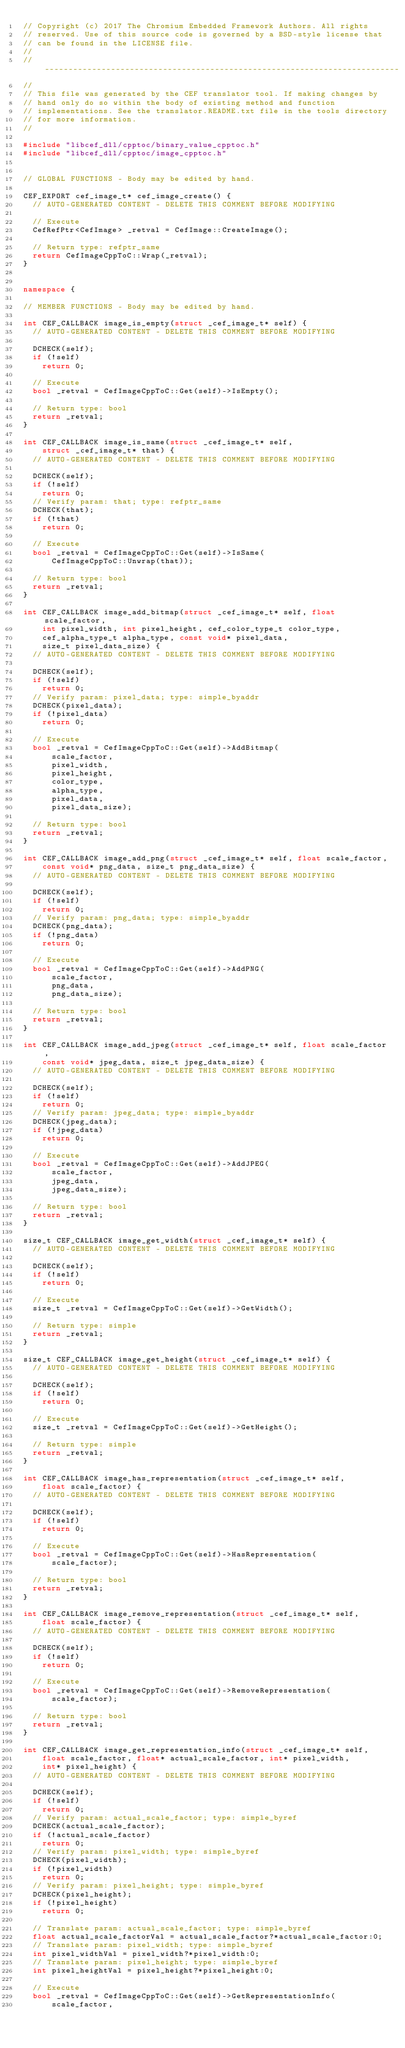<code> <loc_0><loc_0><loc_500><loc_500><_C++_>// Copyright (c) 2017 The Chromium Embedded Framework Authors. All rights
// reserved. Use of this source code is governed by a BSD-style license that
// can be found in the LICENSE file.
//
// ---------------------------------------------------------------------------
//
// This file was generated by the CEF translator tool. If making changes by
// hand only do so within the body of existing method and function
// implementations. See the translator.README.txt file in the tools directory
// for more information.
//

#include "libcef_dll/cpptoc/binary_value_cpptoc.h"
#include "libcef_dll/cpptoc/image_cpptoc.h"


// GLOBAL FUNCTIONS - Body may be edited by hand.

CEF_EXPORT cef_image_t* cef_image_create() {
  // AUTO-GENERATED CONTENT - DELETE THIS COMMENT BEFORE MODIFYING

  // Execute
  CefRefPtr<CefImage> _retval = CefImage::CreateImage();

  // Return type: refptr_same
  return CefImageCppToC::Wrap(_retval);
}


namespace {

// MEMBER FUNCTIONS - Body may be edited by hand.

int CEF_CALLBACK image_is_empty(struct _cef_image_t* self) {
  // AUTO-GENERATED CONTENT - DELETE THIS COMMENT BEFORE MODIFYING

  DCHECK(self);
  if (!self)
    return 0;

  // Execute
  bool _retval = CefImageCppToC::Get(self)->IsEmpty();

  // Return type: bool
  return _retval;
}

int CEF_CALLBACK image_is_same(struct _cef_image_t* self,
    struct _cef_image_t* that) {
  // AUTO-GENERATED CONTENT - DELETE THIS COMMENT BEFORE MODIFYING

  DCHECK(self);
  if (!self)
    return 0;
  // Verify param: that; type: refptr_same
  DCHECK(that);
  if (!that)
    return 0;

  // Execute
  bool _retval = CefImageCppToC::Get(self)->IsSame(
      CefImageCppToC::Unwrap(that));

  // Return type: bool
  return _retval;
}

int CEF_CALLBACK image_add_bitmap(struct _cef_image_t* self, float scale_factor,
    int pixel_width, int pixel_height, cef_color_type_t color_type,
    cef_alpha_type_t alpha_type, const void* pixel_data,
    size_t pixel_data_size) {
  // AUTO-GENERATED CONTENT - DELETE THIS COMMENT BEFORE MODIFYING

  DCHECK(self);
  if (!self)
    return 0;
  // Verify param: pixel_data; type: simple_byaddr
  DCHECK(pixel_data);
  if (!pixel_data)
    return 0;

  // Execute
  bool _retval = CefImageCppToC::Get(self)->AddBitmap(
      scale_factor,
      pixel_width,
      pixel_height,
      color_type,
      alpha_type,
      pixel_data,
      pixel_data_size);

  // Return type: bool
  return _retval;
}

int CEF_CALLBACK image_add_png(struct _cef_image_t* self, float scale_factor,
    const void* png_data, size_t png_data_size) {
  // AUTO-GENERATED CONTENT - DELETE THIS COMMENT BEFORE MODIFYING

  DCHECK(self);
  if (!self)
    return 0;
  // Verify param: png_data; type: simple_byaddr
  DCHECK(png_data);
  if (!png_data)
    return 0;

  // Execute
  bool _retval = CefImageCppToC::Get(self)->AddPNG(
      scale_factor,
      png_data,
      png_data_size);

  // Return type: bool
  return _retval;
}

int CEF_CALLBACK image_add_jpeg(struct _cef_image_t* self, float scale_factor,
    const void* jpeg_data, size_t jpeg_data_size) {
  // AUTO-GENERATED CONTENT - DELETE THIS COMMENT BEFORE MODIFYING

  DCHECK(self);
  if (!self)
    return 0;
  // Verify param: jpeg_data; type: simple_byaddr
  DCHECK(jpeg_data);
  if (!jpeg_data)
    return 0;

  // Execute
  bool _retval = CefImageCppToC::Get(self)->AddJPEG(
      scale_factor,
      jpeg_data,
      jpeg_data_size);

  // Return type: bool
  return _retval;
}

size_t CEF_CALLBACK image_get_width(struct _cef_image_t* self) {
  // AUTO-GENERATED CONTENT - DELETE THIS COMMENT BEFORE MODIFYING

  DCHECK(self);
  if (!self)
    return 0;

  // Execute
  size_t _retval = CefImageCppToC::Get(self)->GetWidth();

  // Return type: simple
  return _retval;
}

size_t CEF_CALLBACK image_get_height(struct _cef_image_t* self) {
  // AUTO-GENERATED CONTENT - DELETE THIS COMMENT BEFORE MODIFYING

  DCHECK(self);
  if (!self)
    return 0;

  // Execute
  size_t _retval = CefImageCppToC::Get(self)->GetHeight();

  // Return type: simple
  return _retval;
}

int CEF_CALLBACK image_has_representation(struct _cef_image_t* self,
    float scale_factor) {
  // AUTO-GENERATED CONTENT - DELETE THIS COMMENT BEFORE MODIFYING

  DCHECK(self);
  if (!self)
    return 0;

  // Execute
  bool _retval = CefImageCppToC::Get(self)->HasRepresentation(
      scale_factor);

  // Return type: bool
  return _retval;
}

int CEF_CALLBACK image_remove_representation(struct _cef_image_t* self,
    float scale_factor) {
  // AUTO-GENERATED CONTENT - DELETE THIS COMMENT BEFORE MODIFYING

  DCHECK(self);
  if (!self)
    return 0;

  // Execute
  bool _retval = CefImageCppToC::Get(self)->RemoveRepresentation(
      scale_factor);

  // Return type: bool
  return _retval;
}

int CEF_CALLBACK image_get_representation_info(struct _cef_image_t* self,
    float scale_factor, float* actual_scale_factor, int* pixel_width,
    int* pixel_height) {
  // AUTO-GENERATED CONTENT - DELETE THIS COMMENT BEFORE MODIFYING

  DCHECK(self);
  if (!self)
    return 0;
  // Verify param: actual_scale_factor; type: simple_byref
  DCHECK(actual_scale_factor);
  if (!actual_scale_factor)
    return 0;
  // Verify param: pixel_width; type: simple_byref
  DCHECK(pixel_width);
  if (!pixel_width)
    return 0;
  // Verify param: pixel_height; type: simple_byref
  DCHECK(pixel_height);
  if (!pixel_height)
    return 0;

  // Translate param: actual_scale_factor; type: simple_byref
  float actual_scale_factorVal = actual_scale_factor?*actual_scale_factor:0;
  // Translate param: pixel_width; type: simple_byref
  int pixel_widthVal = pixel_width?*pixel_width:0;
  // Translate param: pixel_height; type: simple_byref
  int pixel_heightVal = pixel_height?*pixel_height:0;

  // Execute
  bool _retval = CefImageCppToC::Get(self)->GetRepresentationInfo(
      scale_factor,</code> 